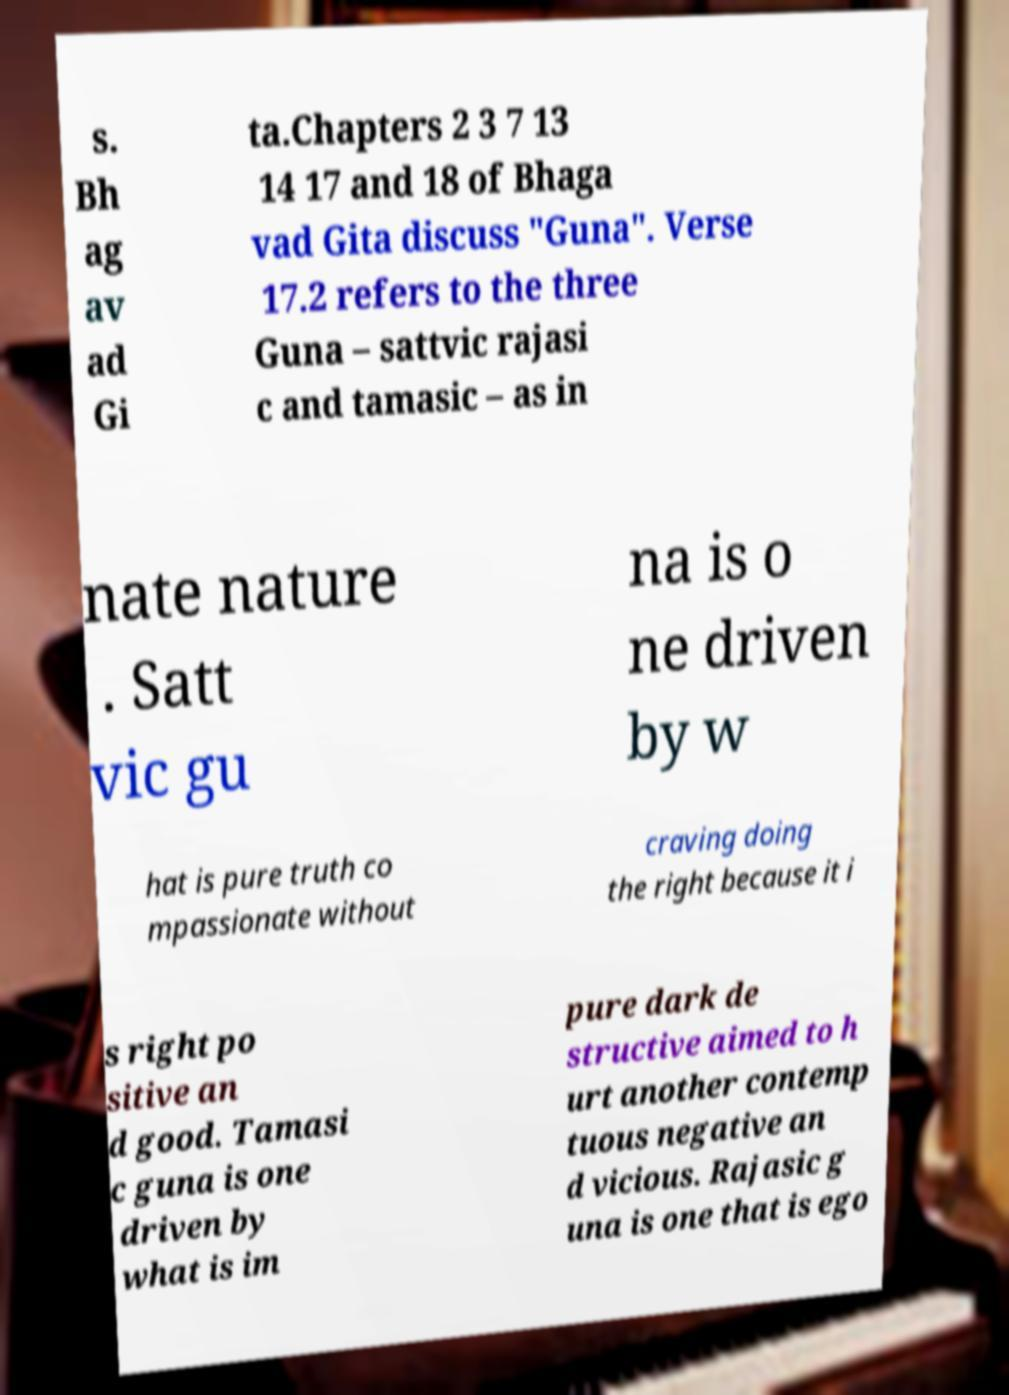Could you assist in decoding the text presented in this image and type it out clearly? s. Bh ag av ad Gi ta.Chapters 2 3 7 13 14 17 and 18 of Bhaga vad Gita discuss "Guna". Verse 17.2 refers to the three Guna – sattvic rajasi c and tamasic – as in nate nature . Satt vic gu na is o ne driven by w hat is pure truth co mpassionate without craving doing the right because it i s right po sitive an d good. Tamasi c guna is one driven by what is im pure dark de structive aimed to h urt another contemp tuous negative an d vicious. Rajasic g una is one that is ego 